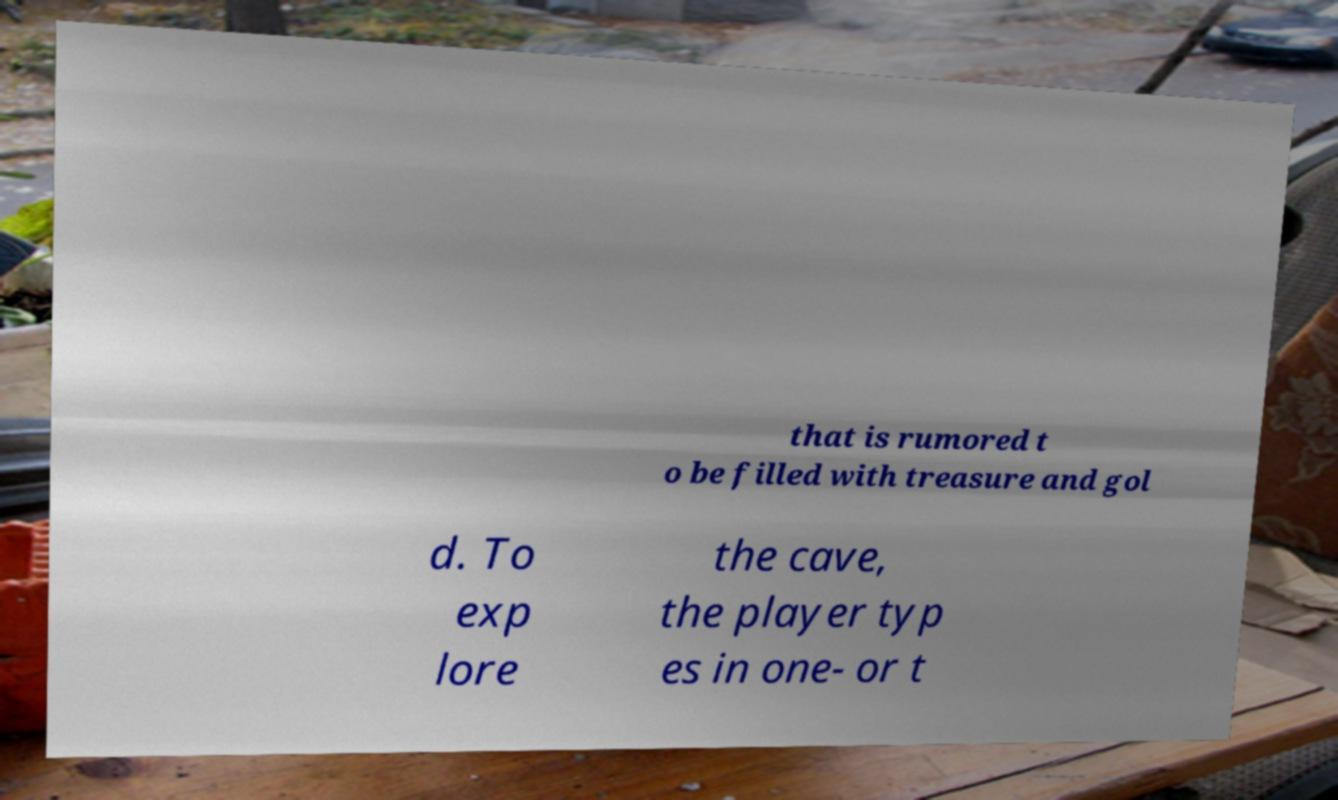What messages or text are displayed in this image? I need them in a readable, typed format. that is rumored t o be filled with treasure and gol d. To exp lore the cave, the player typ es in one- or t 